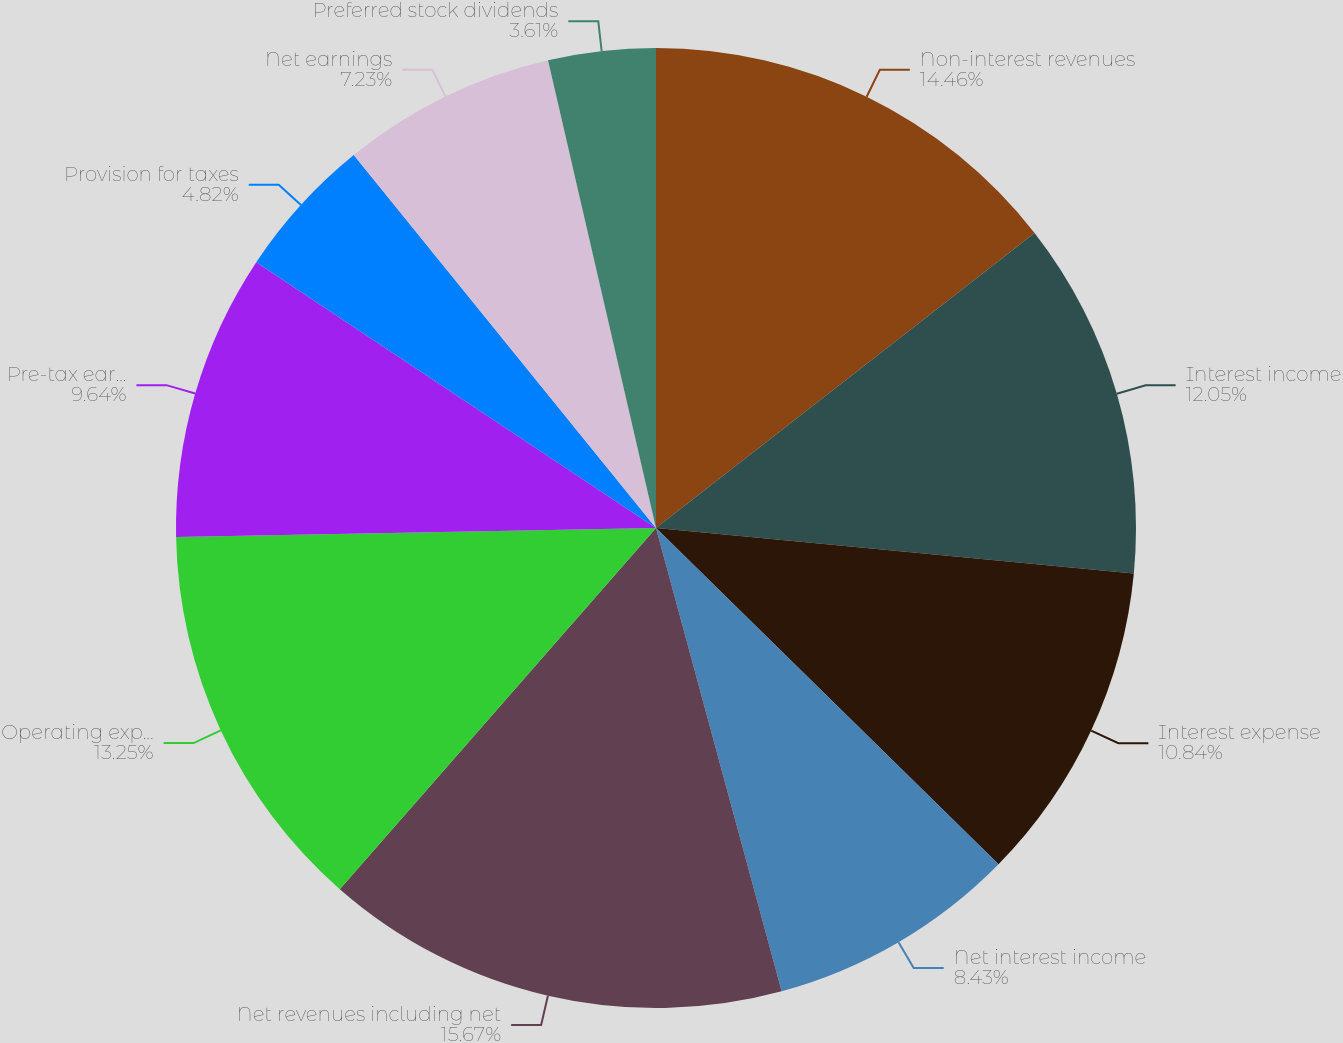<chart> <loc_0><loc_0><loc_500><loc_500><pie_chart><fcel>Non-interest revenues<fcel>Interest income<fcel>Interest expense<fcel>Net interest income<fcel>Net revenues including net<fcel>Operating expenses 1<fcel>Pre-tax earnings<fcel>Provision for taxes<fcel>Net earnings<fcel>Preferred stock dividends<nl><fcel>14.46%<fcel>12.05%<fcel>10.84%<fcel>8.43%<fcel>15.66%<fcel>13.25%<fcel>9.64%<fcel>4.82%<fcel>7.23%<fcel>3.61%<nl></chart> 